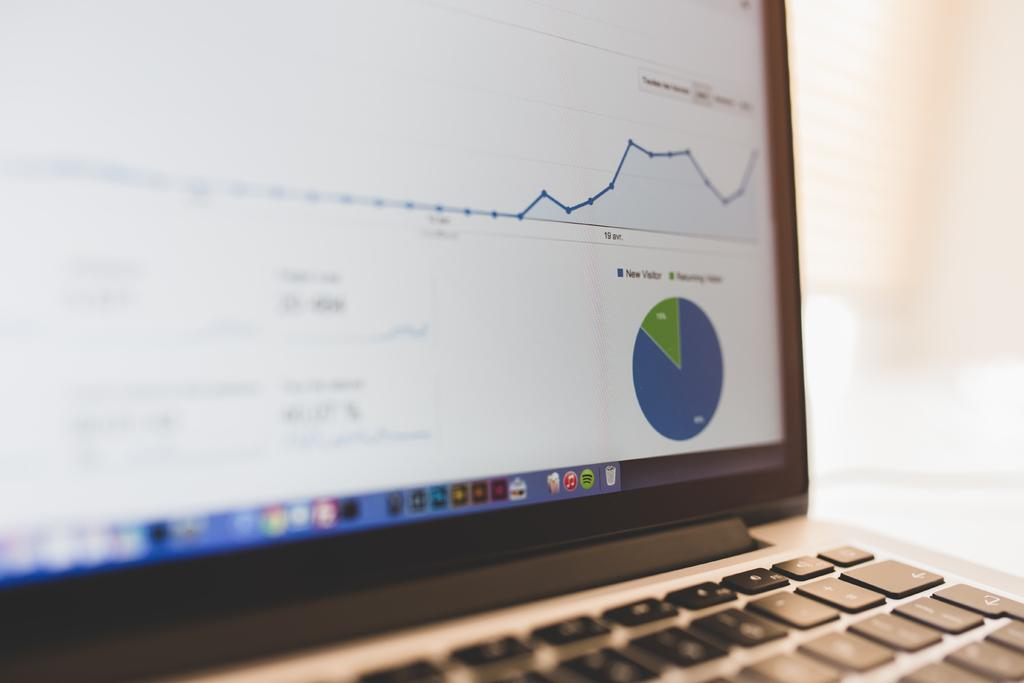<image>
Present a compact description of the photo's key features. different graphs show information about new and returning visitors 